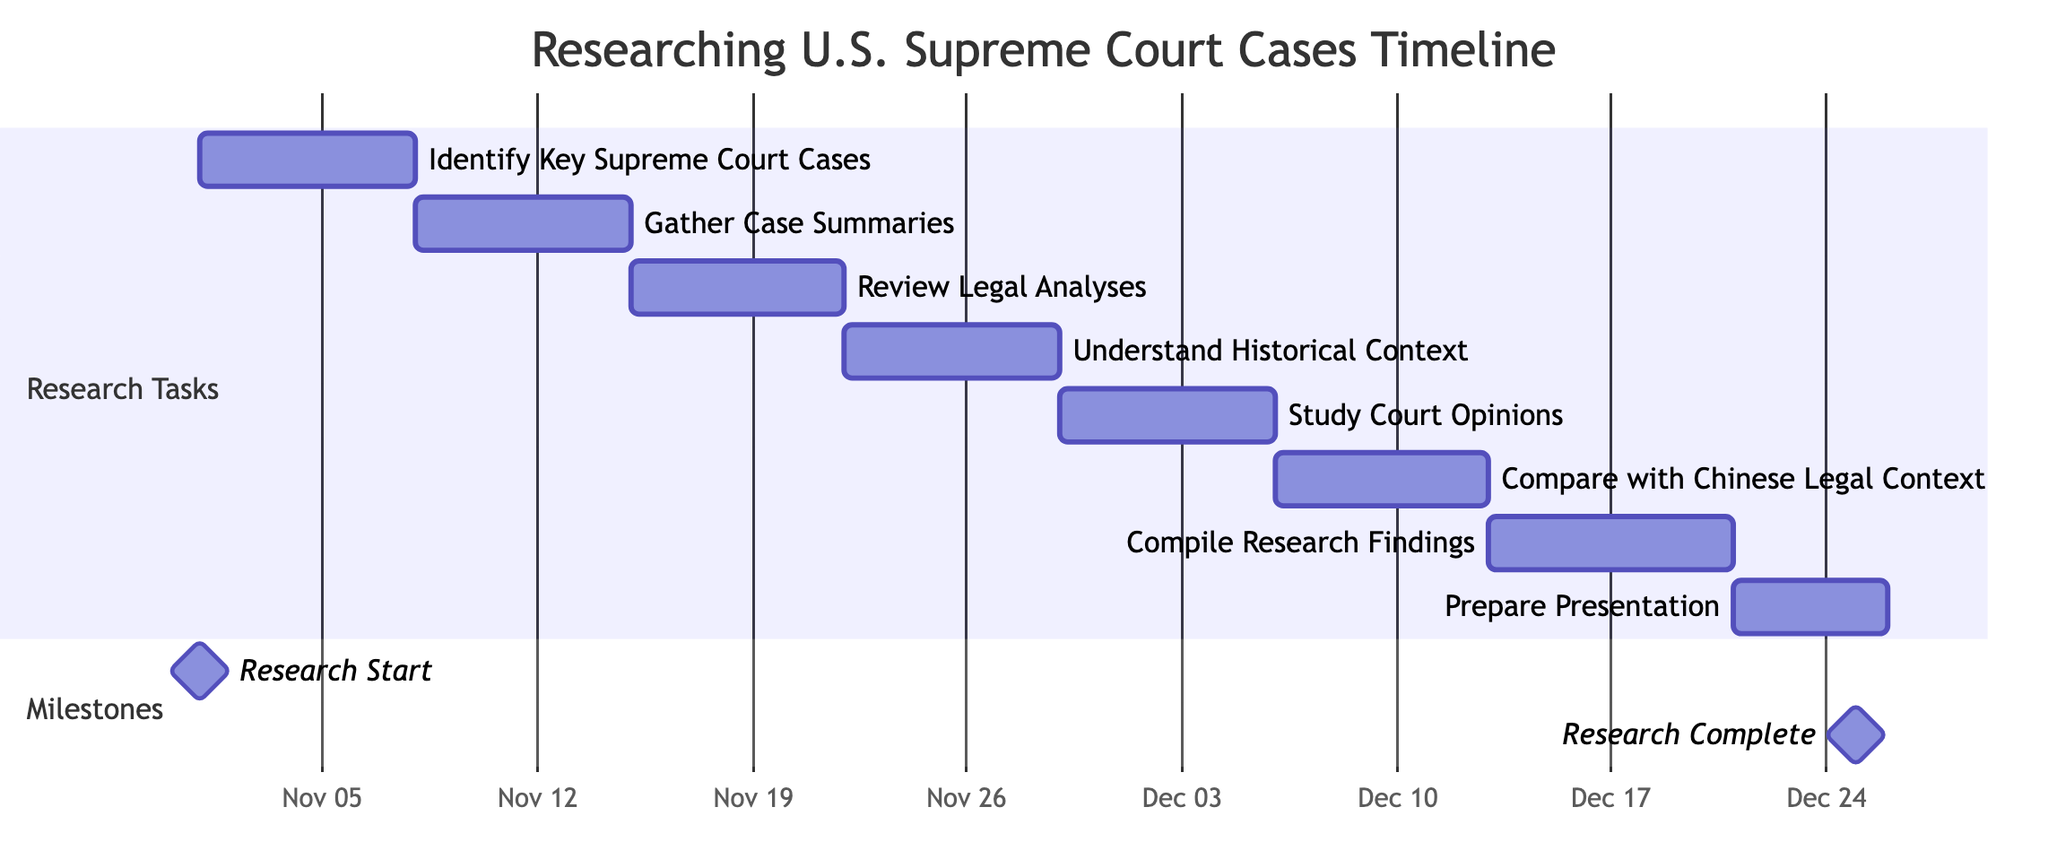What is the duration of the task "Gather Case Summaries"? The task "Gather Case Summaries" starts on November 8, 2023, and ends on November 14, 2023. This gives it a total duration of 7 days.
Answer: 7 days What is the start date of the task "Prepare Presentation"? The task "Prepare Presentation" is scheduled to start after "Compile Research Findings," which ends on December 20, 2023. Therefore, it begins on December 21, 2023.
Answer: December 21, 2023 How many tasks are listed before "Compare with Chinese Legal Context"? The tasks listed before "Compare with Chinese Legal Context" are "Identify Key Supreme Court Cases," "Gather Case Summaries," "Review Legal Analyses," and "Understand Historical Context," totaling 4 tasks.
Answer: 4 tasks What are the names of the first two tasks in the timeline? The first two tasks in the timeline are "Identify Key Supreme Court Cases" and "Gather Case Summaries."
Answer: Identify Key Supreme Court Cases, Gather Case Summaries How many days is the overall research timeline from start to finish? The overall research timeline starts on November 1, 2023, and finishes on December 25, 2023. The total duration is 55 days.
Answer: 55 days What is the milestone labeled "Research Complete" scheduled to occur? The milestone "Research Complete" is labeled to occur on December 25, 2023, marking the end of the research timeline.
Answer: December 25, 2023 Which task immediately follows "Understand Historical Context"? The task that immediately follows "Understand Historical Context" is "Study Court Opinions."
Answer: Study Court Opinions What is the total number of research tasks listed in the Gantt chart? There are 8 research tasks listed in the Gantt chart, including different stages of research focused on U.S. Supreme Court cases.
Answer: 8 tasks 